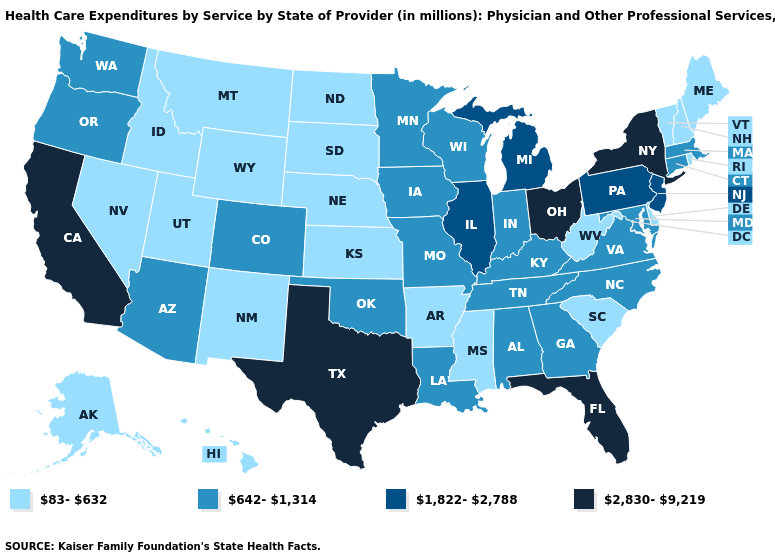Which states have the highest value in the USA?
Short answer required. California, Florida, New York, Ohio, Texas. Name the states that have a value in the range 642-1,314?
Write a very short answer. Alabama, Arizona, Colorado, Connecticut, Georgia, Indiana, Iowa, Kentucky, Louisiana, Maryland, Massachusetts, Minnesota, Missouri, North Carolina, Oklahoma, Oregon, Tennessee, Virginia, Washington, Wisconsin. Does Arizona have the lowest value in the West?
Concise answer only. No. Does Arizona have the same value as Washington?
Keep it brief. Yes. What is the lowest value in states that border Wisconsin?
Concise answer only. 642-1,314. Name the states that have a value in the range 1,822-2,788?
Keep it brief. Illinois, Michigan, New Jersey, Pennsylvania. What is the highest value in the USA?
Keep it brief. 2,830-9,219. What is the highest value in the USA?
Concise answer only. 2,830-9,219. Which states have the lowest value in the Northeast?
Concise answer only. Maine, New Hampshire, Rhode Island, Vermont. Name the states that have a value in the range 1,822-2,788?
Answer briefly. Illinois, Michigan, New Jersey, Pennsylvania. Does Rhode Island have the lowest value in the USA?
Answer briefly. Yes. What is the highest value in the Northeast ?
Quick response, please. 2,830-9,219. Does Florida have the highest value in the South?
Write a very short answer. Yes. What is the value of Pennsylvania?
Keep it brief. 1,822-2,788. 